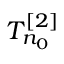<formula> <loc_0><loc_0><loc_500><loc_500>T _ { n _ { 0 } } ^ { [ 2 ] }</formula> 